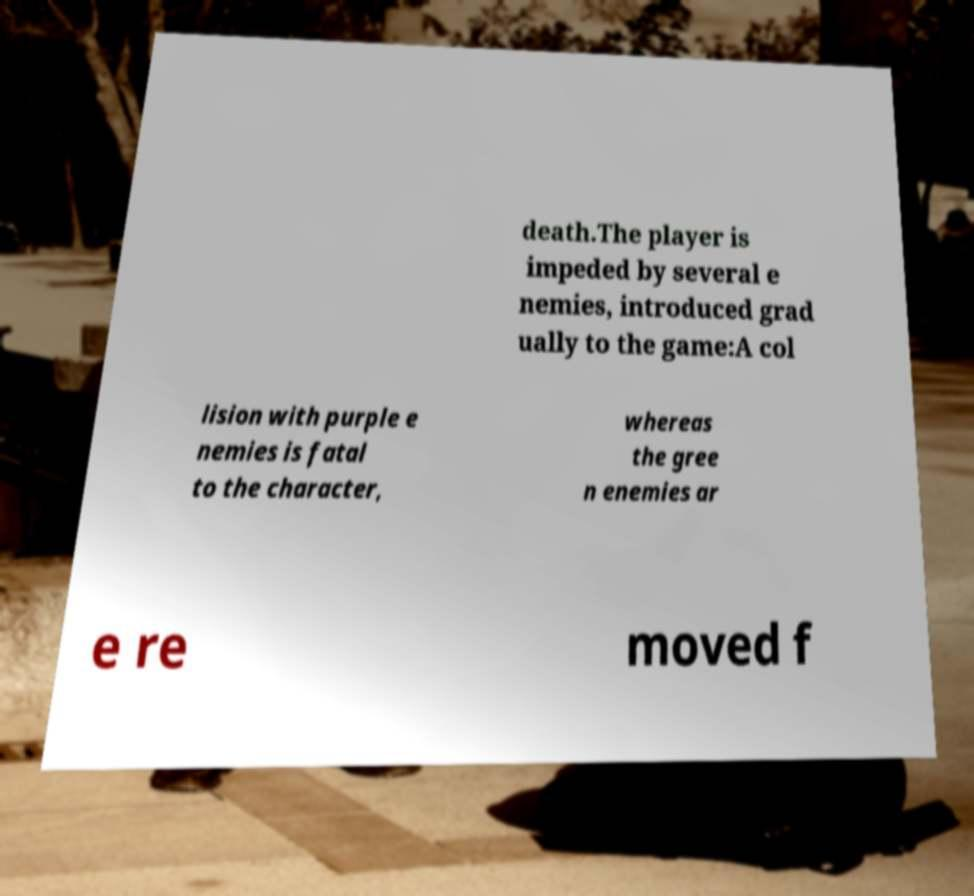Please read and relay the text visible in this image. What does it say? death.The player is impeded by several e nemies, introduced grad ually to the game:A col lision with purple e nemies is fatal to the character, whereas the gree n enemies ar e re moved f 